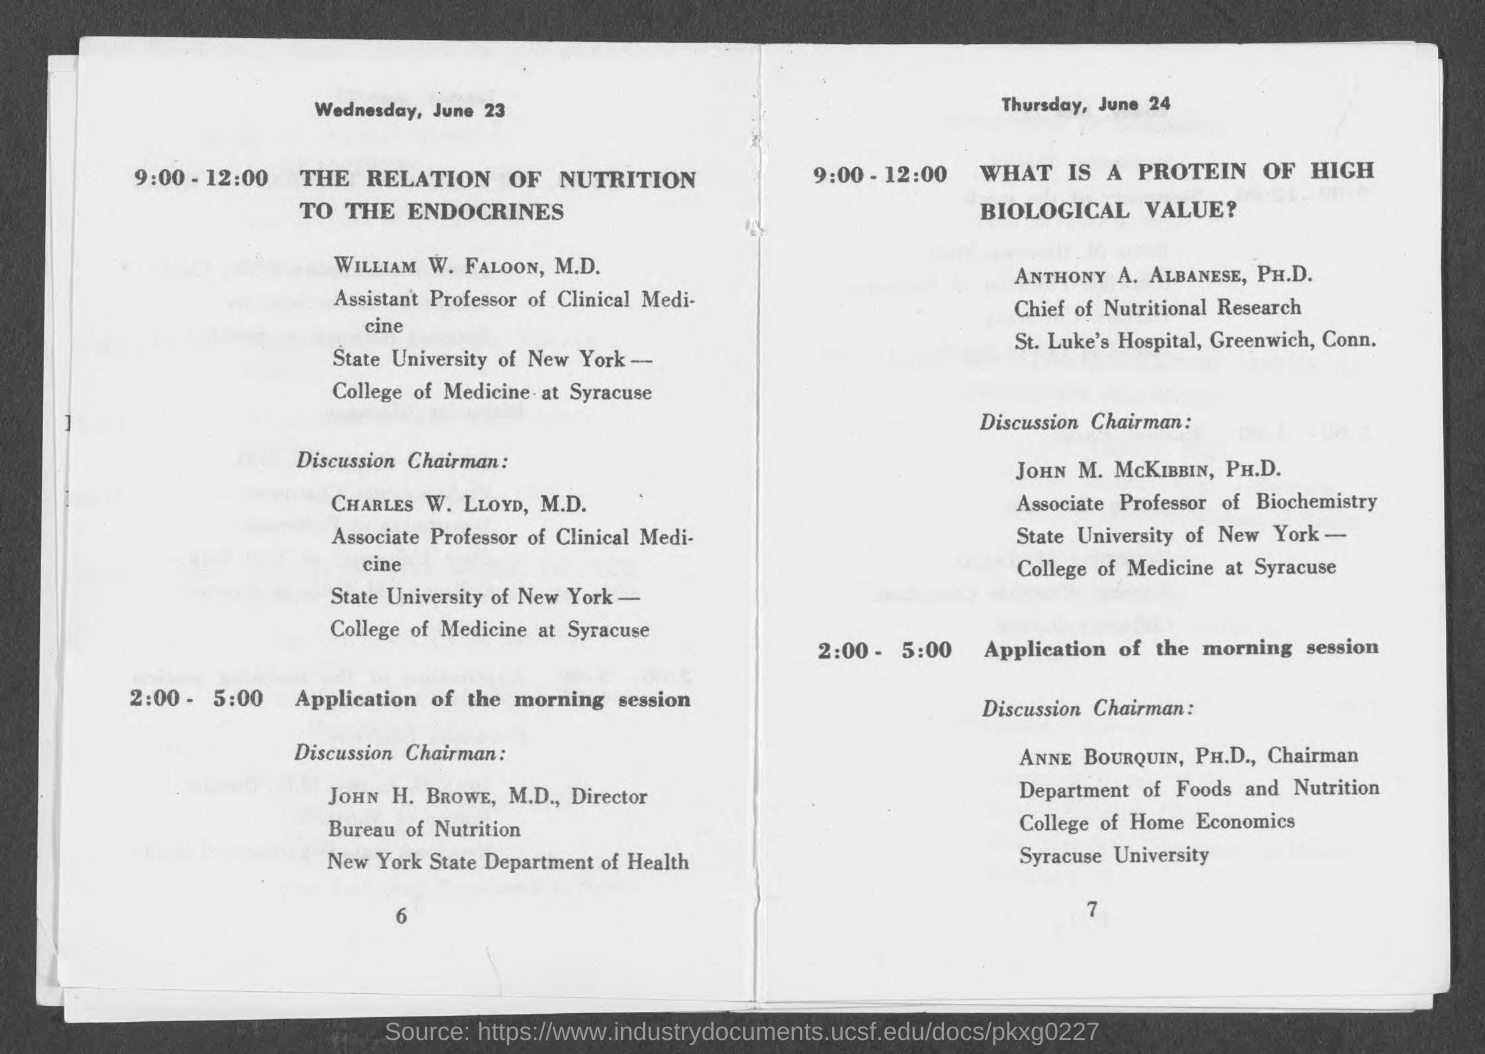Who is the Discussion chairman for application of the morning session on Wednesday, June 23?
Your answer should be very brief. John H. Browe, M.D. Who is the Discussion chairman for application of the morning session on Thursday, June 24?
Provide a succinct answer. Anne Bourquin, PH.D. 